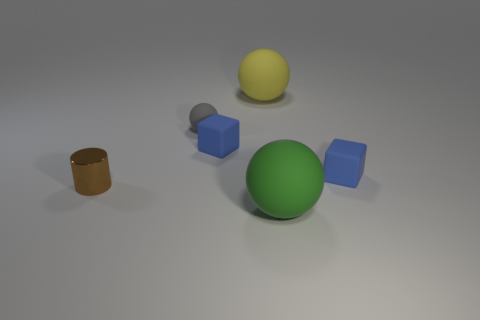Is there a yellow thing of the same size as the gray thing?
Offer a very short reply. No. There is another object that is the same size as the yellow matte thing; what material is it?
Keep it short and to the point. Rubber. Do the matte sphere that is in front of the small gray rubber thing and the cube that is right of the big green rubber sphere have the same size?
Provide a succinct answer. No. How many things are either big yellow metallic things or large green rubber spheres right of the small ball?
Your answer should be very brief. 1. Are there any green rubber objects of the same shape as the big yellow rubber object?
Provide a succinct answer. Yes. How big is the yellow rubber sphere behind the ball that is to the left of the big yellow object?
Your answer should be compact. Large. Is the color of the metal cylinder the same as the tiny matte sphere?
Your response must be concise. No. What number of shiny things are large things or big blue cylinders?
Your answer should be compact. 0. How many tiny metal things are there?
Keep it short and to the point. 1. Is the ball in front of the tiny brown shiny cylinder made of the same material as the object behind the tiny gray rubber ball?
Offer a terse response. Yes. 